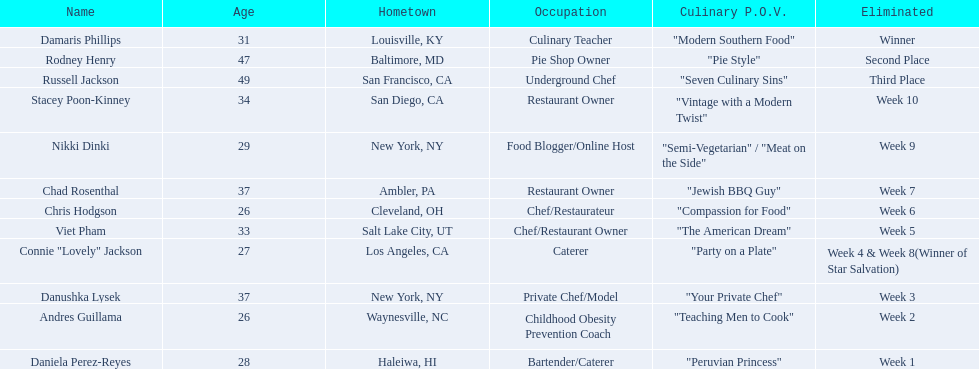Excluding the first, second, and third place winners, which contestants were removed from the competition? Stacey Poon-Kinney, Nikki Dinki, Chad Rosenthal, Chris Hodgson, Viet Pham, Connie "Lovely" Jackson, Danushka Lysek, Andres Guillama, Daniela Perez-Reyes. Who were the five contestants eliminated just before the announcement of the top three winners? Stacey Poon-Kinney, Nikki Dinki, Chad Rosenthal, Chris Hodgson, Viet Pham. Out of these five, who was eliminated earlier, nikki dinki or viet pham? Viet Pham. 